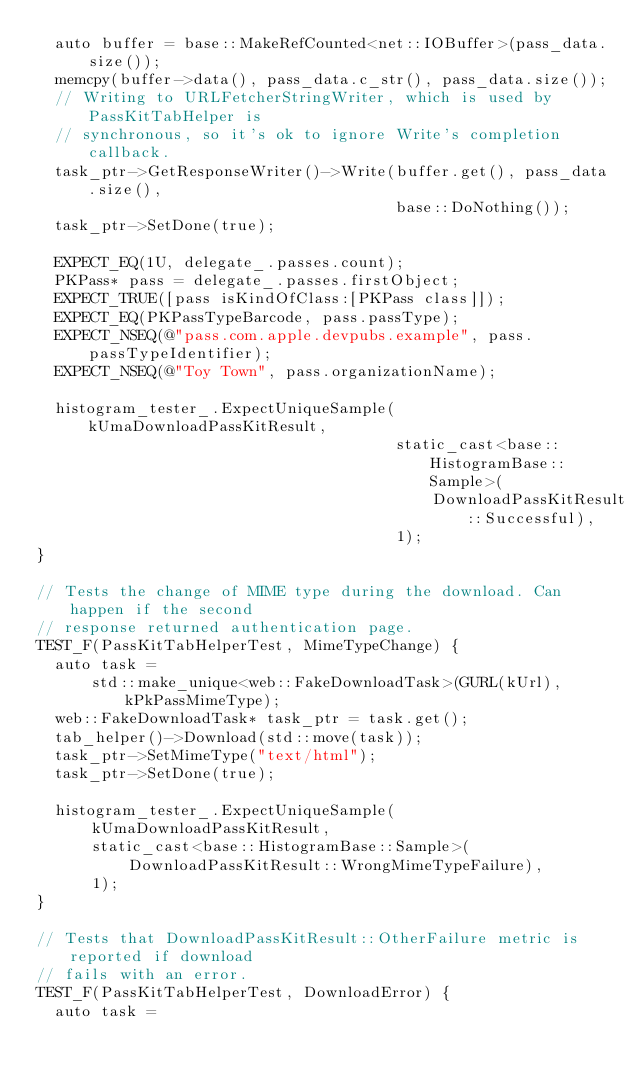<code> <loc_0><loc_0><loc_500><loc_500><_ObjectiveC_>  auto buffer = base::MakeRefCounted<net::IOBuffer>(pass_data.size());
  memcpy(buffer->data(), pass_data.c_str(), pass_data.size());
  // Writing to URLFetcherStringWriter, which is used by PassKitTabHelper is
  // synchronous, so it's ok to ignore Write's completion callback.
  task_ptr->GetResponseWriter()->Write(buffer.get(), pass_data.size(),
                                       base::DoNothing());
  task_ptr->SetDone(true);

  EXPECT_EQ(1U, delegate_.passes.count);
  PKPass* pass = delegate_.passes.firstObject;
  EXPECT_TRUE([pass isKindOfClass:[PKPass class]]);
  EXPECT_EQ(PKPassTypeBarcode, pass.passType);
  EXPECT_NSEQ(@"pass.com.apple.devpubs.example", pass.passTypeIdentifier);
  EXPECT_NSEQ(@"Toy Town", pass.organizationName);

  histogram_tester_.ExpectUniqueSample(kUmaDownloadPassKitResult,
                                       static_cast<base::HistogramBase::Sample>(
                                           DownloadPassKitResult::Successful),
                                       1);
}

// Tests the change of MIME type during the download. Can happen if the second
// response returned authentication page.
TEST_F(PassKitTabHelperTest, MimeTypeChange) {
  auto task =
      std::make_unique<web::FakeDownloadTask>(GURL(kUrl), kPkPassMimeType);
  web::FakeDownloadTask* task_ptr = task.get();
  tab_helper()->Download(std::move(task));
  task_ptr->SetMimeType("text/html");
  task_ptr->SetDone(true);

  histogram_tester_.ExpectUniqueSample(
      kUmaDownloadPassKitResult,
      static_cast<base::HistogramBase::Sample>(
          DownloadPassKitResult::WrongMimeTypeFailure),
      1);
}

// Tests that DownloadPassKitResult::OtherFailure metric is reported if download
// fails with an error.
TEST_F(PassKitTabHelperTest, DownloadError) {
  auto task =</code> 